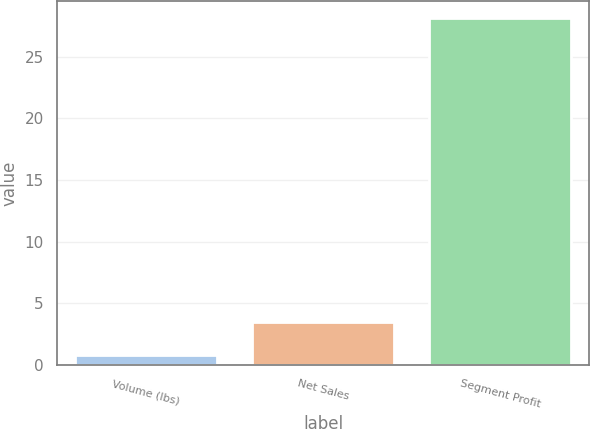Convert chart to OTSL. <chart><loc_0><loc_0><loc_500><loc_500><bar_chart><fcel>Volume (lbs)<fcel>Net Sales<fcel>Segment Profit<nl><fcel>0.8<fcel>3.53<fcel>28.1<nl></chart> 